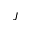Convert formula to latex. <formula><loc_0><loc_0><loc_500><loc_500>J</formula> 